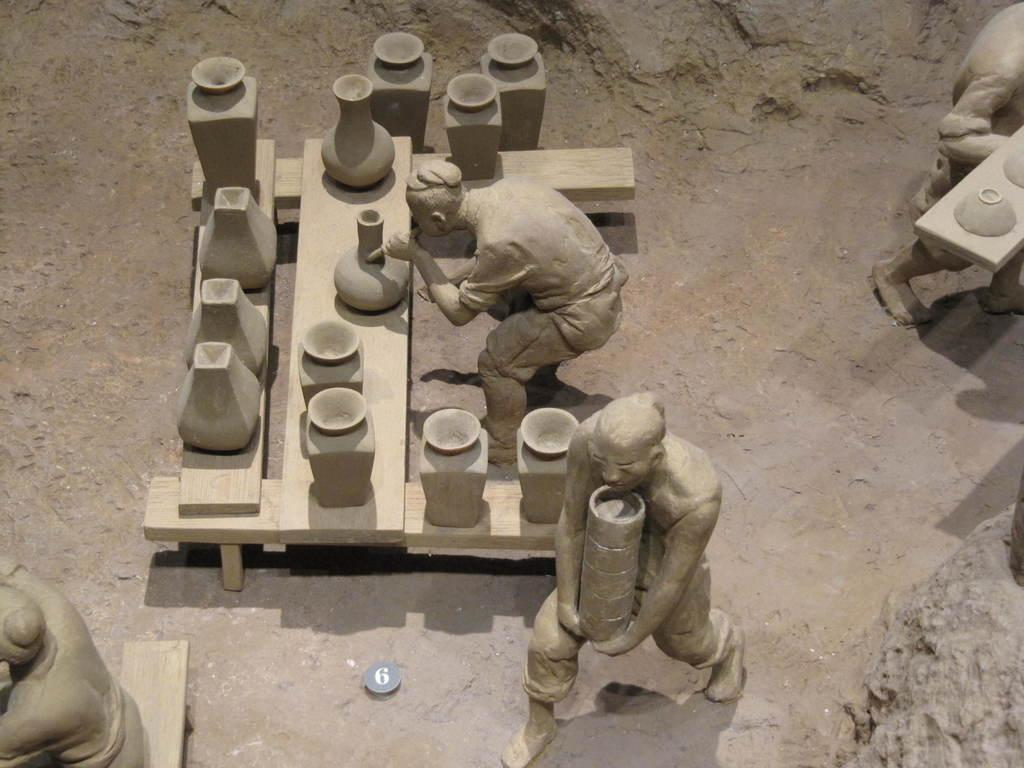What type of objects can be seen in the image? There are statues and bowls in the image. What is the color of the surface on which the bowls are placed? The surface on which the bowls are placed is cream-colored. How does the girl interact with the statues in the image? There is no girl present in the image, so it is not possible to answer that question. 